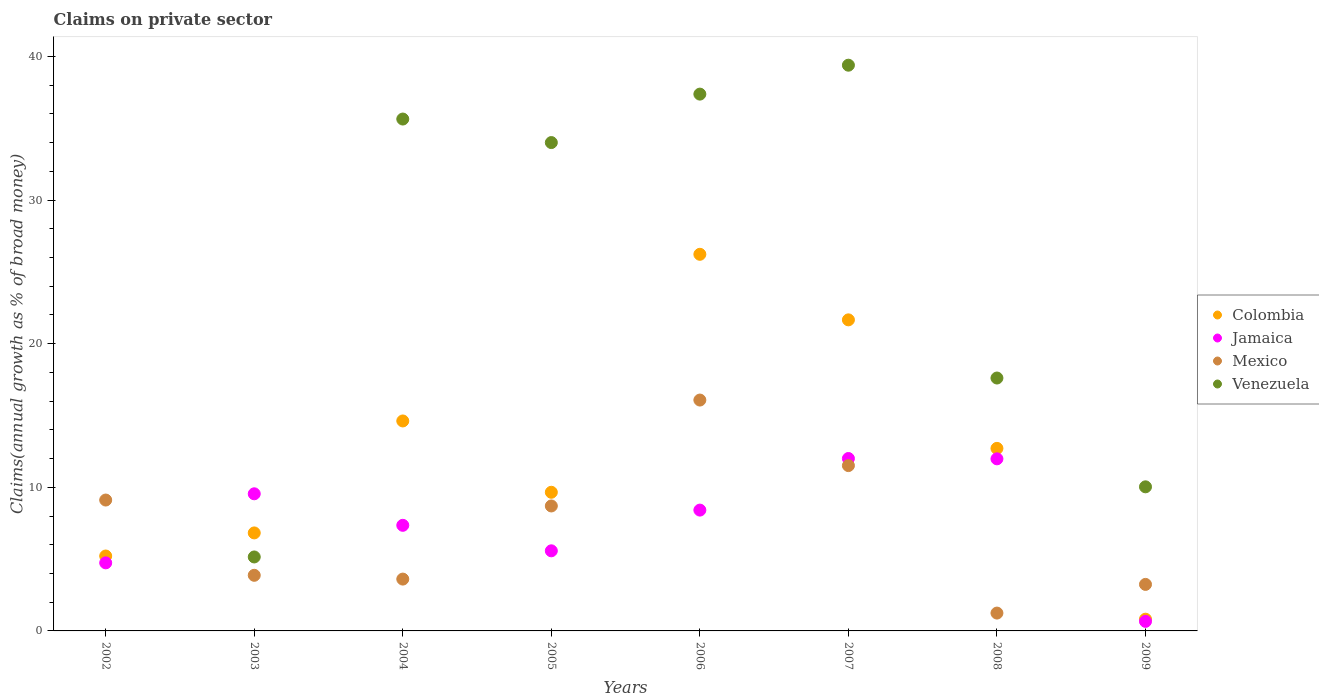How many different coloured dotlines are there?
Your answer should be very brief. 4. Is the number of dotlines equal to the number of legend labels?
Your answer should be compact. No. What is the percentage of broad money claimed on private sector in Colombia in 2008?
Your answer should be compact. 12.71. Across all years, what is the maximum percentage of broad money claimed on private sector in Mexico?
Your response must be concise. 16.08. Across all years, what is the minimum percentage of broad money claimed on private sector in Colombia?
Make the answer very short. 0.82. In which year was the percentage of broad money claimed on private sector in Colombia maximum?
Provide a short and direct response. 2006. What is the total percentage of broad money claimed on private sector in Colombia in the graph?
Provide a succinct answer. 97.73. What is the difference between the percentage of broad money claimed on private sector in Jamaica in 2002 and that in 2003?
Provide a succinct answer. -4.81. What is the difference between the percentage of broad money claimed on private sector in Venezuela in 2003 and the percentage of broad money claimed on private sector in Jamaica in 2007?
Provide a succinct answer. -6.86. What is the average percentage of broad money claimed on private sector in Venezuela per year?
Keep it short and to the point. 22.4. In the year 2007, what is the difference between the percentage of broad money claimed on private sector in Jamaica and percentage of broad money claimed on private sector in Venezuela?
Keep it short and to the point. -27.39. In how many years, is the percentage of broad money claimed on private sector in Colombia greater than 6 %?
Your answer should be compact. 6. What is the ratio of the percentage of broad money claimed on private sector in Venezuela in 2005 to that in 2008?
Offer a very short reply. 1.93. Is the percentage of broad money claimed on private sector in Mexico in 2003 less than that in 2004?
Your answer should be very brief. No. What is the difference between the highest and the second highest percentage of broad money claimed on private sector in Venezuela?
Make the answer very short. 2.01. What is the difference between the highest and the lowest percentage of broad money claimed on private sector in Mexico?
Your response must be concise. 14.83. In how many years, is the percentage of broad money claimed on private sector in Mexico greater than the average percentage of broad money claimed on private sector in Mexico taken over all years?
Give a very brief answer. 4. Is it the case that in every year, the sum of the percentage of broad money claimed on private sector in Jamaica and percentage of broad money claimed on private sector in Colombia  is greater than the percentage of broad money claimed on private sector in Mexico?
Your answer should be very brief. No. How many years are there in the graph?
Your answer should be compact. 8. What is the difference between two consecutive major ticks on the Y-axis?
Keep it short and to the point. 10. How many legend labels are there?
Provide a short and direct response. 4. How are the legend labels stacked?
Give a very brief answer. Vertical. What is the title of the graph?
Make the answer very short. Claims on private sector. Does "Ireland" appear as one of the legend labels in the graph?
Provide a succinct answer. No. What is the label or title of the Y-axis?
Ensure brevity in your answer.  Claims(annual growth as % of broad money). What is the Claims(annual growth as % of broad money) of Colombia in 2002?
Offer a terse response. 5.22. What is the Claims(annual growth as % of broad money) in Jamaica in 2002?
Provide a succinct answer. 4.74. What is the Claims(annual growth as % of broad money) of Mexico in 2002?
Provide a succinct answer. 9.11. What is the Claims(annual growth as % of broad money) in Colombia in 2003?
Your answer should be compact. 6.82. What is the Claims(annual growth as % of broad money) of Jamaica in 2003?
Provide a succinct answer. 9.55. What is the Claims(annual growth as % of broad money) of Mexico in 2003?
Offer a terse response. 3.87. What is the Claims(annual growth as % of broad money) in Venezuela in 2003?
Keep it short and to the point. 5.15. What is the Claims(annual growth as % of broad money) of Colombia in 2004?
Offer a terse response. 14.62. What is the Claims(annual growth as % of broad money) of Jamaica in 2004?
Your answer should be very brief. 7.35. What is the Claims(annual growth as % of broad money) in Mexico in 2004?
Offer a very short reply. 3.61. What is the Claims(annual growth as % of broad money) in Venezuela in 2004?
Provide a short and direct response. 35.64. What is the Claims(annual growth as % of broad money) of Colombia in 2005?
Keep it short and to the point. 9.66. What is the Claims(annual growth as % of broad money) in Jamaica in 2005?
Your response must be concise. 5.58. What is the Claims(annual growth as % of broad money) in Mexico in 2005?
Offer a very short reply. 8.7. What is the Claims(annual growth as % of broad money) in Venezuela in 2005?
Make the answer very short. 34.01. What is the Claims(annual growth as % of broad money) of Colombia in 2006?
Offer a terse response. 26.22. What is the Claims(annual growth as % of broad money) in Jamaica in 2006?
Give a very brief answer. 8.41. What is the Claims(annual growth as % of broad money) of Mexico in 2006?
Offer a terse response. 16.08. What is the Claims(annual growth as % of broad money) of Venezuela in 2006?
Offer a terse response. 37.38. What is the Claims(annual growth as % of broad money) of Colombia in 2007?
Your response must be concise. 21.66. What is the Claims(annual growth as % of broad money) in Jamaica in 2007?
Make the answer very short. 12.01. What is the Claims(annual growth as % of broad money) in Mexico in 2007?
Offer a very short reply. 11.51. What is the Claims(annual growth as % of broad money) in Venezuela in 2007?
Provide a succinct answer. 39.39. What is the Claims(annual growth as % of broad money) of Colombia in 2008?
Provide a succinct answer. 12.71. What is the Claims(annual growth as % of broad money) of Jamaica in 2008?
Make the answer very short. 11.98. What is the Claims(annual growth as % of broad money) in Mexico in 2008?
Make the answer very short. 1.24. What is the Claims(annual growth as % of broad money) in Venezuela in 2008?
Keep it short and to the point. 17.61. What is the Claims(annual growth as % of broad money) in Colombia in 2009?
Provide a succinct answer. 0.82. What is the Claims(annual growth as % of broad money) in Jamaica in 2009?
Your answer should be very brief. 0.66. What is the Claims(annual growth as % of broad money) of Mexico in 2009?
Your response must be concise. 3.24. What is the Claims(annual growth as % of broad money) of Venezuela in 2009?
Offer a terse response. 10.03. Across all years, what is the maximum Claims(annual growth as % of broad money) of Colombia?
Provide a succinct answer. 26.22. Across all years, what is the maximum Claims(annual growth as % of broad money) of Jamaica?
Your answer should be compact. 12.01. Across all years, what is the maximum Claims(annual growth as % of broad money) in Mexico?
Your response must be concise. 16.08. Across all years, what is the maximum Claims(annual growth as % of broad money) in Venezuela?
Provide a short and direct response. 39.39. Across all years, what is the minimum Claims(annual growth as % of broad money) of Colombia?
Ensure brevity in your answer.  0.82. Across all years, what is the minimum Claims(annual growth as % of broad money) of Jamaica?
Provide a short and direct response. 0.66. Across all years, what is the minimum Claims(annual growth as % of broad money) in Mexico?
Keep it short and to the point. 1.24. Across all years, what is the minimum Claims(annual growth as % of broad money) in Venezuela?
Your answer should be very brief. 0. What is the total Claims(annual growth as % of broad money) in Colombia in the graph?
Ensure brevity in your answer.  97.73. What is the total Claims(annual growth as % of broad money) of Jamaica in the graph?
Ensure brevity in your answer.  60.29. What is the total Claims(annual growth as % of broad money) in Mexico in the graph?
Offer a very short reply. 57.37. What is the total Claims(annual growth as % of broad money) in Venezuela in the graph?
Offer a terse response. 179.22. What is the difference between the Claims(annual growth as % of broad money) in Colombia in 2002 and that in 2003?
Your answer should be very brief. -1.61. What is the difference between the Claims(annual growth as % of broad money) of Jamaica in 2002 and that in 2003?
Make the answer very short. -4.81. What is the difference between the Claims(annual growth as % of broad money) of Mexico in 2002 and that in 2003?
Your answer should be very brief. 5.24. What is the difference between the Claims(annual growth as % of broad money) of Colombia in 2002 and that in 2004?
Offer a very short reply. -9.4. What is the difference between the Claims(annual growth as % of broad money) of Jamaica in 2002 and that in 2004?
Offer a terse response. -2.61. What is the difference between the Claims(annual growth as % of broad money) of Mexico in 2002 and that in 2004?
Give a very brief answer. 5.5. What is the difference between the Claims(annual growth as % of broad money) in Colombia in 2002 and that in 2005?
Keep it short and to the point. -4.44. What is the difference between the Claims(annual growth as % of broad money) of Jamaica in 2002 and that in 2005?
Provide a succinct answer. -0.84. What is the difference between the Claims(annual growth as % of broad money) of Mexico in 2002 and that in 2005?
Make the answer very short. 0.41. What is the difference between the Claims(annual growth as % of broad money) of Colombia in 2002 and that in 2006?
Offer a very short reply. -21.01. What is the difference between the Claims(annual growth as % of broad money) in Jamaica in 2002 and that in 2006?
Offer a terse response. -3.67. What is the difference between the Claims(annual growth as % of broad money) in Mexico in 2002 and that in 2006?
Offer a very short reply. -6.96. What is the difference between the Claims(annual growth as % of broad money) in Colombia in 2002 and that in 2007?
Your answer should be compact. -16.44. What is the difference between the Claims(annual growth as % of broad money) of Jamaica in 2002 and that in 2007?
Keep it short and to the point. -7.27. What is the difference between the Claims(annual growth as % of broad money) of Mexico in 2002 and that in 2007?
Give a very brief answer. -2.4. What is the difference between the Claims(annual growth as % of broad money) of Colombia in 2002 and that in 2008?
Provide a short and direct response. -7.5. What is the difference between the Claims(annual growth as % of broad money) of Jamaica in 2002 and that in 2008?
Offer a very short reply. -7.24. What is the difference between the Claims(annual growth as % of broad money) in Mexico in 2002 and that in 2008?
Offer a very short reply. 7.87. What is the difference between the Claims(annual growth as % of broad money) of Colombia in 2002 and that in 2009?
Your response must be concise. 4.4. What is the difference between the Claims(annual growth as % of broad money) in Jamaica in 2002 and that in 2009?
Your response must be concise. 4.08. What is the difference between the Claims(annual growth as % of broad money) in Mexico in 2002 and that in 2009?
Your answer should be very brief. 5.87. What is the difference between the Claims(annual growth as % of broad money) of Colombia in 2003 and that in 2004?
Offer a very short reply. -7.8. What is the difference between the Claims(annual growth as % of broad money) of Jamaica in 2003 and that in 2004?
Keep it short and to the point. 2.19. What is the difference between the Claims(annual growth as % of broad money) of Mexico in 2003 and that in 2004?
Make the answer very short. 0.26. What is the difference between the Claims(annual growth as % of broad money) of Venezuela in 2003 and that in 2004?
Your response must be concise. -30.49. What is the difference between the Claims(annual growth as % of broad money) in Colombia in 2003 and that in 2005?
Make the answer very short. -2.83. What is the difference between the Claims(annual growth as % of broad money) of Jamaica in 2003 and that in 2005?
Offer a very short reply. 3.97. What is the difference between the Claims(annual growth as % of broad money) of Mexico in 2003 and that in 2005?
Keep it short and to the point. -4.83. What is the difference between the Claims(annual growth as % of broad money) of Venezuela in 2003 and that in 2005?
Provide a short and direct response. -28.86. What is the difference between the Claims(annual growth as % of broad money) of Colombia in 2003 and that in 2006?
Your answer should be very brief. -19.4. What is the difference between the Claims(annual growth as % of broad money) of Jamaica in 2003 and that in 2006?
Make the answer very short. 1.14. What is the difference between the Claims(annual growth as % of broad money) of Mexico in 2003 and that in 2006?
Offer a terse response. -12.2. What is the difference between the Claims(annual growth as % of broad money) in Venezuela in 2003 and that in 2006?
Ensure brevity in your answer.  -32.23. What is the difference between the Claims(annual growth as % of broad money) of Colombia in 2003 and that in 2007?
Your answer should be very brief. -14.84. What is the difference between the Claims(annual growth as % of broad money) in Jamaica in 2003 and that in 2007?
Offer a terse response. -2.46. What is the difference between the Claims(annual growth as % of broad money) in Mexico in 2003 and that in 2007?
Provide a succinct answer. -7.64. What is the difference between the Claims(annual growth as % of broad money) in Venezuela in 2003 and that in 2007?
Provide a succinct answer. -34.24. What is the difference between the Claims(annual growth as % of broad money) of Colombia in 2003 and that in 2008?
Ensure brevity in your answer.  -5.89. What is the difference between the Claims(annual growth as % of broad money) of Jamaica in 2003 and that in 2008?
Offer a very short reply. -2.43. What is the difference between the Claims(annual growth as % of broad money) in Mexico in 2003 and that in 2008?
Your answer should be compact. 2.63. What is the difference between the Claims(annual growth as % of broad money) of Venezuela in 2003 and that in 2008?
Ensure brevity in your answer.  -12.46. What is the difference between the Claims(annual growth as % of broad money) of Colombia in 2003 and that in 2009?
Your response must be concise. 6.01. What is the difference between the Claims(annual growth as % of broad money) in Jamaica in 2003 and that in 2009?
Keep it short and to the point. 8.88. What is the difference between the Claims(annual growth as % of broad money) in Mexico in 2003 and that in 2009?
Offer a very short reply. 0.63. What is the difference between the Claims(annual growth as % of broad money) in Venezuela in 2003 and that in 2009?
Your response must be concise. -4.88. What is the difference between the Claims(annual growth as % of broad money) of Colombia in 2004 and that in 2005?
Ensure brevity in your answer.  4.97. What is the difference between the Claims(annual growth as % of broad money) in Jamaica in 2004 and that in 2005?
Keep it short and to the point. 1.78. What is the difference between the Claims(annual growth as % of broad money) in Mexico in 2004 and that in 2005?
Your answer should be compact. -5.09. What is the difference between the Claims(annual growth as % of broad money) in Venezuela in 2004 and that in 2005?
Offer a very short reply. 1.64. What is the difference between the Claims(annual growth as % of broad money) in Colombia in 2004 and that in 2006?
Give a very brief answer. -11.6. What is the difference between the Claims(annual growth as % of broad money) of Jamaica in 2004 and that in 2006?
Keep it short and to the point. -1.06. What is the difference between the Claims(annual growth as % of broad money) in Mexico in 2004 and that in 2006?
Offer a very short reply. -12.47. What is the difference between the Claims(annual growth as % of broad money) of Venezuela in 2004 and that in 2006?
Provide a succinct answer. -1.74. What is the difference between the Claims(annual growth as % of broad money) in Colombia in 2004 and that in 2007?
Your answer should be very brief. -7.04. What is the difference between the Claims(annual growth as % of broad money) of Jamaica in 2004 and that in 2007?
Provide a short and direct response. -4.65. What is the difference between the Claims(annual growth as % of broad money) in Mexico in 2004 and that in 2007?
Your response must be concise. -7.9. What is the difference between the Claims(annual growth as % of broad money) of Venezuela in 2004 and that in 2007?
Your response must be concise. -3.75. What is the difference between the Claims(annual growth as % of broad money) of Colombia in 2004 and that in 2008?
Ensure brevity in your answer.  1.91. What is the difference between the Claims(annual growth as % of broad money) of Jamaica in 2004 and that in 2008?
Keep it short and to the point. -4.63. What is the difference between the Claims(annual growth as % of broad money) in Mexico in 2004 and that in 2008?
Give a very brief answer. 2.37. What is the difference between the Claims(annual growth as % of broad money) of Venezuela in 2004 and that in 2008?
Offer a terse response. 18.03. What is the difference between the Claims(annual growth as % of broad money) in Colombia in 2004 and that in 2009?
Your response must be concise. 13.8. What is the difference between the Claims(annual growth as % of broad money) of Jamaica in 2004 and that in 2009?
Make the answer very short. 6.69. What is the difference between the Claims(annual growth as % of broad money) in Mexico in 2004 and that in 2009?
Provide a short and direct response. 0.37. What is the difference between the Claims(annual growth as % of broad money) of Venezuela in 2004 and that in 2009?
Your answer should be very brief. 25.61. What is the difference between the Claims(annual growth as % of broad money) in Colombia in 2005 and that in 2006?
Your answer should be very brief. -16.57. What is the difference between the Claims(annual growth as % of broad money) in Jamaica in 2005 and that in 2006?
Ensure brevity in your answer.  -2.84. What is the difference between the Claims(annual growth as % of broad money) of Mexico in 2005 and that in 2006?
Offer a very short reply. -7.37. What is the difference between the Claims(annual growth as % of broad money) in Venezuela in 2005 and that in 2006?
Your answer should be very brief. -3.37. What is the difference between the Claims(annual growth as % of broad money) of Colombia in 2005 and that in 2007?
Provide a succinct answer. -12.01. What is the difference between the Claims(annual growth as % of broad money) in Jamaica in 2005 and that in 2007?
Provide a short and direct response. -6.43. What is the difference between the Claims(annual growth as % of broad money) of Mexico in 2005 and that in 2007?
Give a very brief answer. -2.81. What is the difference between the Claims(annual growth as % of broad money) in Venezuela in 2005 and that in 2007?
Your answer should be compact. -5.39. What is the difference between the Claims(annual growth as % of broad money) of Colombia in 2005 and that in 2008?
Offer a very short reply. -3.06. What is the difference between the Claims(annual growth as % of broad money) in Jamaica in 2005 and that in 2008?
Keep it short and to the point. -6.41. What is the difference between the Claims(annual growth as % of broad money) of Mexico in 2005 and that in 2008?
Your answer should be very brief. 7.46. What is the difference between the Claims(annual growth as % of broad money) in Venezuela in 2005 and that in 2008?
Make the answer very short. 16.4. What is the difference between the Claims(annual growth as % of broad money) in Colombia in 2005 and that in 2009?
Keep it short and to the point. 8.84. What is the difference between the Claims(annual growth as % of broad money) in Jamaica in 2005 and that in 2009?
Your answer should be compact. 4.91. What is the difference between the Claims(annual growth as % of broad money) in Mexico in 2005 and that in 2009?
Make the answer very short. 5.46. What is the difference between the Claims(annual growth as % of broad money) of Venezuela in 2005 and that in 2009?
Offer a terse response. 23.97. What is the difference between the Claims(annual growth as % of broad money) of Colombia in 2006 and that in 2007?
Offer a very short reply. 4.56. What is the difference between the Claims(annual growth as % of broad money) in Jamaica in 2006 and that in 2007?
Provide a succinct answer. -3.59. What is the difference between the Claims(annual growth as % of broad money) of Mexico in 2006 and that in 2007?
Offer a very short reply. 4.56. What is the difference between the Claims(annual growth as % of broad money) in Venezuela in 2006 and that in 2007?
Your answer should be compact. -2.01. What is the difference between the Claims(annual growth as % of broad money) in Colombia in 2006 and that in 2008?
Your response must be concise. 13.51. What is the difference between the Claims(annual growth as % of broad money) in Jamaica in 2006 and that in 2008?
Ensure brevity in your answer.  -3.57. What is the difference between the Claims(annual growth as % of broad money) in Mexico in 2006 and that in 2008?
Your answer should be compact. 14.83. What is the difference between the Claims(annual growth as % of broad money) of Venezuela in 2006 and that in 2008?
Your answer should be very brief. 19.77. What is the difference between the Claims(annual growth as % of broad money) in Colombia in 2006 and that in 2009?
Give a very brief answer. 25.41. What is the difference between the Claims(annual growth as % of broad money) of Jamaica in 2006 and that in 2009?
Offer a terse response. 7.75. What is the difference between the Claims(annual growth as % of broad money) of Mexico in 2006 and that in 2009?
Ensure brevity in your answer.  12.84. What is the difference between the Claims(annual growth as % of broad money) of Venezuela in 2006 and that in 2009?
Give a very brief answer. 27.35. What is the difference between the Claims(annual growth as % of broad money) in Colombia in 2007 and that in 2008?
Your response must be concise. 8.95. What is the difference between the Claims(annual growth as % of broad money) of Jamaica in 2007 and that in 2008?
Your response must be concise. 0.02. What is the difference between the Claims(annual growth as % of broad money) of Mexico in 2007 and that in 2008?
Offer a very short reply. 10.27. What is the difference between the Claims(annual growth as % of broad money) in Venezuela in 2007 and that in 2008?
Give a very brief answer. 21.78. What is the difference between the Claims(annual growth as % of broad money) of Colombia in 2007 and that in 2009?
Give a very brief answer. 20.84. What is the difference between the Claims(annual growth as % of broad money) in Jamaica in 2007 and that in 2009?
Provide a short and direct response. 11.34. What is the difference between the Claims(annual growth as % of broad money) of Mexico in 2007 and that in 2009?
Your answer should be compact. 8.27. What is the difference between the Claims(annual growth as % of broad money) in Venezuela in 2007 and that in 2009?
Provide a succinct answer. 29.36. What is the difference between the Claims(annual growth as % of broad money) in Colombia in 2008 and that in 2009?
Your answer should be very brief. 11.89. What is the difference between the Claims(annual growth as % of broad money) of Jamaica in 2008 and that in 2009?
Your answer should be very brief. 11.32. What is the difference between the Claims(annual growth as % of broad money) in Mexico in 2008 and that in 2009?
Give a very brief answer. -2. What is the difference between the Claims(annual growth as % of broad money) in Venezuela in 2008 and that in 2009?
Give a very brief answer. 7.58. What is the difference between the Claims(annual growth as % of broad money) of Colombia in 2002 and the Claims(annual growth as % of broad money) of Jamaica in 2003?
Provide a succinct answer. -4.33. What is the difference between the Claims(annual growth as % of broad money) of Colombia in 2002 and the Claims(annual growth as % of broad money) of Mexico in 2003?
Provide a succinct answer. 1.34. What is the difference between the Claims(annual growth as % of broad money) of Colombia in 2002 and the Claims(annual growth as % of broad money) of Venezuela in 2003?
Offer a very short reply. 0.07. What is the difference between the Claims(annual growth as % of broad money) of Jamaica in 2002 and the Claims(annual growth as % of broad money) of Mexico in 2003?
Ensure brevity in your answer.  0.87. What is the difference between the Claims(annual growth as % of broad money) of Jamaica in 2002 and the Claims(annual growth as % of broad money) of Venezuela in 2003?
Your response must be concise. -0.41. What is the difference between the Claims(annual growth as % of broad money) in Mexico in 2002 and the Claims(annual growth as % of broad money) in Venezuela in 2003?
Offer a very short reply. 3.96. What is the difference between the Claims(annual growth as % of broad money) of Colombia in 2002 and the Claims(annual growth as % of broad money) of Jamaica in 2004?
Your response must be concise. -2.14. What is the difference between the Claims(annual growth as % of broad money) in Colombia in 2002 and the Claims(annual growth as % of broad money) in Mexico in 2004?
Your answer should be very brief. 1.61. What is the difference between the Claims(annual growth as % of broad money) in Colombia in 2002 and the Claims(annual growth as % of broad money) in Venezuela in 2004?
Give a very brief answer. -30.43. What is the difference between the Claims(annual growth as % of broad money) in Jamaica in 2002 and the Claims(annual growth as % of broad money) in Mexico in 2004?
Offer a very short reply. 1.13. What is the difference between the Claims(annual growth as % of broad money) of Jamaica in 2002 and the Claims(annual growth as % of broad money) of Venezuela in 2004?
Provide a short and direct response. -30.9. What is the difference between the Claims(annual growth as % of broad money) of Mexico in 2002 and the Claims(annual growth as % of broad money) of Venezuela in 2004?
Your answer should be very brief. -26.53. What is the difference between the Claims(annual growth as % of broad money) in Colombia in 2002 and the Claims(annual growth as % of broad money) in Jamaica in 2005?
Make the answer very short. -0.36. What is the difference between the Claims(annual growth as % of broad money) of Colombia in 2002 and the Claims(annual growth as % of broad money) of Mexico in 2005?
Provide a short and direct response. -3.48. What is the difference between the Claims(annual growth as % of broad money) in Colombia in 2002 and the Claims(annual growth as % of broad money) in Venezuela in 2005?
Give a very brief answer. -28.79. What is the difference between the Claims(annual growth as % of broad money) of Jamaica in 2002 and the Claims(annual growth as % of broad money) of Mexico in 2005?
Offer a terse response. -3.96. What is the difference between the Claims(annual growth as % of broad money) of Jamaica in 2002 and the Claims(annual growth as % of broad money) of Venezuela in 2005?
Make the answer very short. -29.27. What is the difference between the Claims(annual growth as % of broad money) of Mexico in 2002 and the Claims(annual growth as % of broad money) of Venezuela in 2005?
Offer a very short reply. -24.89. What is the difference between the Claims(annual growth as % of broad money) in Colombia in 2002 and the Claims(annual growth as % of broad money) in Jamaica in 2006?
Give a very brief answer. -3.2. What is the difference between the Claims(annual growth as % of broad money) of Colombia in 2002 and the Claims(annual growth as % of broad money) of Mexico in 2006?
Offer a very short reply. -10.86. What is the difference between the Claims(annual growth as % of broad money) of Colombia in 2002 and the Claims(annual growth as % of broad money) of Venezuela in 2006?
Offer a terse response. -32.16. What is the difference between the Claims(annual growth as % of broad money) of Jamaica in 2002 and the Claims(annual growth as % of broad money) of Mexico in 2006?
Keep it short and to the point. -11.34. What is the difference between the Claims(annual growth as % of broad money) of Jamaica in 2002 and the Claims(annual growth as % of broad money) of Venezuela in 2006?
Provide a succinct answer. -32.64. What is the difference between the Claims(annual growth as % of broad money) in Mexico in 2002 and the Claims(annual growth as % of broad money) in Venezuela in 2006?
Make the answer very short. -28.27. What is the difference between the Claims(annual growth as % of broad money) of Colombia in 2002 and the Claims(annual growth as % of broad money) of Jamaica in 2007?
Keep it short and to the point. -6.79. What is the difference between the Claims(annual growth as % of broad money) in Colombia in 2002 and the Claims(annual growth as % of broad money) in Mexico in 2007?
Provide a short and direct response. -6.3. What is the difference between the Claims(annual growth as % of broad money) in Colombia in 2002 and the Claims(annual growth as % of broad money) in Venezuela in 2007?
Give a very brief answer. -34.18. What is the difference between the Claims(annual growth as % of broad money) of Jamaica in 2002 and the Claims(annual growth as % of broad money) of Mexico in 2007?
Make the answer very short. -6.77. What is the difference between the Claims(annual growth as % of broad money) of Jamaica in 2002 and the Claims(annual growth as % of broad money) of Venezuela in 2007?
Provide a short and direct response. -34.65. What is the difference between the Claims(annual growth as % of broad money) of Mexico in 2002 and the Claims(annual growth as % of broad money) of Venezuela in 2007?
Give a very brief answer. -30.28. What is the difference between the Claims(annual growth as % of broad money) of Colombia in 2002 and the Claims(annual growth as % of broad money) of Jamaica in 2008?
Your response must be concise. -6.77. What is the difference between the Claims(annual growth as % of broad money) of Colombia in 2002 and the Claims(annual growth as % of broad money) of Mexico in 2008?
Give a very brief answer. 3.97. What is the difference between the Claims(annual growth as % of broad money) in Colombia in 2002 and the Claims(annual growth as % of broad money) in Venezuela in 2008?
Your response must be concise. -12.39. What is the difference between the Claims(annual growth as % of broad money) in Jamaica in 2002 and the Claims(annual growth as % of broad money) in Mexico in 2008?
Make the answer very short. 3.5. What is the difference between the Claims(annual growth as % of broad money) in Jamaica in 2002 and the Claims(annual growth as % of broad money) in Venezuela in 2008?
Your response must be concise. -12.87. What is the difference between the Claims(annual growth as % of broad money) of Mexico in 2002 and the Claims(annual growth as % of broad money) of Venezuela in 2008?
Keep it short and to the point. -8.5. What is the difference between the Claims(annual growth as % of broad money) in Colombia in 2002 and the Claims(annual growth as % of broad money) in Jamaica in 2009?
Keep it short and to the point. 4.55. What is the difference between the Claims(annual growth as % of broad money) in Colombia in 2002 and the Claims(annual growth as % of broad money) in Mexico in 2009?
Your answer should be compact. 1.98. What is the difference between the Claims(annual growth as % of broad money) of Colombia in 2002 and the Claims(annual growth as % of broad money) of Venezuela in 2009?
Keep it short and to the point. -4.82. What is the difference between the Claims(annual growth as % of broad money) in Jamaica in 2002 and the Claims(annual growth as % of broad money) in Mexico in 2009?
Keep it short and to the point. 1.5. What is the difference between the Claims(annual growth as % of broad money) in Jamaica in 2002 and the Claims(annual growth as % of broad money) in Venezuela in 2009?
Your answer should be very brief. -5.29. What is the difference between the Claims(annual growth as % of broad money) in Mexico in 2002 and the Claims(annual growth as % of broad money) in Venezuela in 2009?
Your answer should be very brief. -0.92. What is the difference between the Claims(annual growth as % of broad money) in Colombia in 2003 and the Claims(annual growth as % of broad money) in Jamaica in 2004?
Your response must be concise. -0.53. What is the difference between the Claims(annual growth as % of broad money) of Colombia in 2003 and the Claims(annual growth as % of broad money) of Mexico in 2004?
Your answer should be compact. 3.22. What is the difference between the Claims(annual growth as % of broad money) in Colombia in 2003 and the Claims(annual growth as % of broad money) in Venezuela in 2004?
Give a very brief answer. -28.82. What is the difference between the Claims(annual growth as % of broad money) in Jamaica in 2003 and the Claims(annual growth as % of broad money) in Mexico in 2004?
Keep it short and to the point. 5.94. What is the difference between the Claims(annual growth as % of broad money) in Jamaica in 2003 and the Claims(annual growth as % of broad money) in Venezuela in 2004?
Make the answer very short. -26.1. What is the difference between the Claims(annual growth as % of broad money) of Mexico in 2003 and the Claims(annual growth as % of broad money) of Venezuela in 2004?
Make the answer very short. -31.77. What is the difference between the Claims(annual growth as % of broad money) in Colombia in 2003 and the Claims(annual growth as % of broad money) in Jamaica in 2005?
Provide a short and direct response. 1.25. What is the difference between the Claims(annual growth as % of broad money) of Colombia in 2003 and the Claims(annual growth as % of broad money) of Mexico in 2005?
Your answer should be very brief. -1.88. What is the difference between the Claims(annual growth as % of broad money) in Colombia in 2003 and the Claims(annual growth as % of broad money) in Venezuela in 2005?
Provide a short and direct response. -27.18. What is the difference between the Claims(annual growth as % of broad money) in Jamaica in 2003 and the Claims(annual growth as % of broad money) in Mexico in 2005?
Your answer should be compact. 0.85. What is the difference between the Claims(annual growth as % of broad money) in Jamaica in 2003 and the Claims(annual growth as % of broad money) in Venezuela in 2005?
Your response must be concise. -24.46. What is the difference between the Claims(annual growth as % of broad money) in Mexico in 2003 and the Claims(annual growth as % of broad money) in Venezuela in 2005?
Offer a very short reply. -30.13. What is the difference between the Claims(annual growth as % of broad money) in Colombia in 2003 and the Claims(annual growth as % of broad money) in Jamaica in 2006?
Offer a very short reply. -1.59. What is the difference between the Claims(annual growth as % of broad money) of Colombia in 2003 and the Claims(annual growth as % of broad money) of Mexico in 2006?
Provide a short and direct response. -9.25. What is the difference between the Claims(annual growth as % of broad money) of Colombia in 2003 and the Claims(annual growth as % of broad money) of Venezuela in 2006?
Keep it short and to the point. -30.56. What is the difference between the Claims(annual growth as % of broad money) of Jamaica in 2003 and the Claims(annual growth as % of broad money) of Mexico in 2006?
Offer a very short reply. -6.53. What is the difference between the Claims(annual growth as % of broad money) in Jamaica in 2003 and the Claims(annual growth as % of broad money) in Venezuela in 2006?
Provide a short and direct response. -27.83. What is the difference between the Claims(annual growth as % of broad money) in Mexico in 2003 and the Claims(annual growth as % of broad money) in Venezuela in 2006?
Offer a terse response. -33.51. What is the difference between the Claims(annual growth as % of broad money) in Colombia in 2003 and the Claims(annual growth as % of broad money) in Jamaica in 2007?
Your answer should be compact. -5.18. What is the difference between the Claims(annual growth as % of broad money) of Colombia in 2003 and the Claims(annual growth as % of broad money) of Mexico in 2007?
Keep it short and to the point. -4.69. What is the difference between the Claims(annual growth as % of broad money) of Colombia in 2003 and the Claims(annual growth as % of broad money) of Venezuela in 2007?
Keep it short and to the point. -32.57. What is the difference between the Claims(annual growth as % of broad money) of Jamaica in 2003 and the Claims(annual growth as % of broad money) of Mexico in 2007?
Make the answer very short. -1.96. What is the difference between the Claims(annual growth as % of broad money) in Jamaica in 2003 and the Claims(annual growth as % of broad money) in Venezuela in 2007?
Your answer should be compact. -29.85. What is the difference between the Claims(annual growth as % of broad money) in Mexico in 2003 and the Claims(annual growth as % of broad money) in Venezuela in 2007?
Keep it short and to the point. -35.52. What is the difference between the Claims(annual growth as % of broad money) of Colombia in 2003 and the Claims(annual growth as % of broad money) of Jamaica in 2008?
Your answer should be very brief. -5.16. What is the difference between the Claims(annual growth as % of broad money) in Colombia in 2003 and the Claims(annual growth as % of broad money) in Mexico in 2008?
Your answer should be very brief. 5.58. What is the difference between the Claims(annual growth as % of broad money) in Colombia in 2003 and the Claims(annual growth as % of broad money) in Venezuela in 2008?
Provide a succinct answer. -10.79. What is the difference between the Claims(annual growth as % of broad money) in Jamaica in 2003 and the Claims(annual growth as % of broad money) in Mexico in 2008?
Your answer should be very brief. 8.31. What is the difference between the Claims(annual growth as % of broad money) in Jamaica in 2003 and the Claims(annual growth as % of broad money) in Venezuela in 2008?
Your answer should be compact. -8.06. What is the difference between the Claims(annual growth as % of broad money) in Mexico in 2003 and the Claims(annual growth as % of broad money) in Venezuela in 2008?
Your answer should be very brief. -13.74. What is the difference between the Claims(annual growth as % of broad money) of Colombia in 2003 and the Claims(annual growth as % of broad money) of Jamaica in 2009?
Ensure brevity in your answer.  6.16. What is the difference between the Claims(annual growth as % of broad money) of Colombia in 2003 and the Claims(annual growth as % of broad money) of Mexico in 2009?
Give a very brief answer. 3.58. What is the difference between the Claims(annual growth as % of broad money) of Colombia in 2003 and the Claims(annual growth as % of broad money) of Venezuela in 2009?
Offer a very short reply. -3.21. What is the difference between the Claims(annual growth as % of broad money) in Jamaica in 2003 and the Claims(annual growth as % of broad money) in Mexico in 2009?
Offer a very short reply. 6.31. What is the difference between the Claims(annual growth as % of broad money) in Jamaica in 2003 and the Claims(annual growth as % of broad money) in Venezuela in 2009?
Your answer should be compact. -0.49. What is the difference between the Claims(annual growth as % of broad money) of Mexico in 2003 and the Claims(annual growth as % of broad money) of Venezuela in 2009?
Your answer should be very brief. -6.16. What is the difference between the Claims(annual growth as % of broad money) in Colombia in 2004 and the Claims(annual growth as % of broad money) in Jamaica in 2005?
Provide a succinct answer. 9.04. What is the difference between the Claims(annual growth as % of broad money) in Colombia in 2004 and the Claims(annual growth as % of broad money) in Mexico in 2005?
Give a very brief answer. 5.92. What is the difference between the Claims(annual growth as % of broad money) in Colombia in 2004 and the Claims(annual growth as % of broad money) in Venezuela in 2005?
Provide a short and direct response. -19.38. What is the difference between the Claims(annual growth as % of broad money) in Jamaica in 2004 and the Claims(annual growth as % of broad money) in Mexico in 2005?
Your response must be concise. -1.35. What is the difference between the Claims(annual growth as % of broad money) in Jamaica in 2004 and the Claims(annual growth as % of broad money) in Venezuela in 2005?
Your response must be concise. -26.65. What is the difference between the Claims(annual growth as % of broad money) of Mexico in 2004 and the Claims(annual growth as % of broad money) of Venezuela in 2005?
Make the answer very short. -30.4. What is the difference between the Claims(annual growth as % of broad money) in Colombia in 2004 and the Claims(annual growth as % of broad money) in Jamaica in 2006?
Make the answer very short. 6.21. What is the difference between the Claims(annual growth as % of broad money) of Colombia in 2004 and the Claims(annual growth as % of broad money) of Mexico in 2006?
Your answer should be very brief. -1.46. What is the difference between the Claims(annual growth as % of broad money) of Colombia in 2004 and the Claims(annual growth as % of broad money) of Venezuela in 2006?
Your response must be concise. -22.76. What is the difference between the Claims(annual growth as % of broad money) in Jamaica in 2004 and the Claims(annual growth as % of broad money) in Mexico in 2006?
Ensure brevity in your answer.  -8.72. What is the difference between the Claims(annual growth as % of broad money) in Jamaica in 2004 and the Claims(annual growth as % of broad money) in Venezuela in 2006?
Make the answer very short. -30.03. What is the difference between the Claims(annual growth as % of broad money) in Mexico in 2004 and the Claims(annual growth as % of broad money) in Venezuela in 2006?
Keep it short and to the point. -33.77. What is the difference between the Claims(annual growth as % of broad money) in Colombia in 2004 and the Claims(annual growth as % of broad money) in Jamaica in 2007?
Offer a very short reply. 2.62. What is the difference between the Claims(annual growth as % of broad money) in Colombia in 2004 and the Claims(annual growth as % of broad money) in Mexico in 2007?
Offer a terse response. 3.11. What is the difference between the Claims(annual growth as % of broad money) in Colombia in 2004 and the Claims(annual growth as % of broad money) in Venezuela in 2007?
Give a very brief answer. -24.77. What is the difference between the Claims(annual growth as % of broad money) of Jamaica in 2004 and the Claims(annual growth as % of broad money) of Mexico in 2007?
Your answer should be very brief. -4.16. What is the difference between the Claims(annual growth as % of broad money) in Jamaica in 2004 and the Claims(annual growth as % of broad money) in Venezuela in 2007?
Provide a short and direct response. -32.04. What is the difference between the Claims(annual growth as % of broad money) of Mexico in 2004 and the Claims(annual growth as % of broad money) of Venezuela in 2007?
Provide a succinct answer. -35.78. What is the difference between the Claims(annual growth as % of broad money) of Colombia in 2004 and the Claims(annual growth as % of broad money) of Jamaica in 2008?
Provide a succinct answer. 2.64. What is the difference between the Claims(annual growth as % of broad money) of Colombia in 2004 and the Claims(annual growth as % of broad money) of Mexico in 2008?
Provide a short and direct response. 13.38. What is the difference between the Claims(annual growth as % of broad money) in Colombia in 2004 and the Claims(annual growth as % of broad money) in Venezuela in 2008?
Make the answer very short. -2.99. What is the difference between the Claims(annual growth as % of broad money) of Jamaica in 2004 and the Claims(annual growth as % of broad money) of Mexico in 2008?
Provide a short and direct response. 6.11. What is the difference between the Claims(annual growth as % of broad money) of Jamaica in 2004 and the Claims(annual growth as % of broad money) of Venezuela in 2008?
Offer a very short reply. -10.26. What is the difference between the Claims(annual growth as % of broad money) in Mexico in 2004 and the Claims(annual growth as % of broad money) in Venezuela in 2008?
Provide a short and direct response. -14. What is the difference between the Claims(annual growth as % of broad money) of Colombia in 2004 and the Claims(annual growth as % of broad money) of Jamaica in 2009?
Ensure brevity in your answer.  13.96. What is the difference between the Claims(annual growth as % of broad money) of Colombia in 2004 and the Claims(annual growth as % of broad money) of Mexico in 2009?
Provide a short and direct response. 11.38. What is the difference between the Claims(annual growth as % of broad money) in Colombia in 2004 and the Claims(annual growth as % of broad money) in Venezuela in 2009?
Provide a short and direct response. 4.59. What is the difference between the Claims(annual growth as % of broad money) of Jamaica in 2004 and the Claims(annual growth as % of broad money) of Mexico in 2009?
Your answer should be very brief. 4.11. What is the difference between the Claims(annual growth as % of broad money) of Jamaica in 2004 and the Claims(annual growth as % of broad money) of Venezuela in 2009?
Offer a terse response. -2.68. What is the difference between the Claims(annual growth as % of broad money) of Mexico in 2004 and the Claims(annual growth as % of broad money) of Venezuela in 2009?
Keep it short and to the point. -6.42. What is the difference between the Claims(annual growth as % of broad money) of Colombia in 2005 and the Claims(annual growth as % of broad money) of Jamaica in 2006?
Your answer should be very brief. 1.24. What is the difference between the Claims(annual growth as % of broad money) in Colombia in 2005 and the Claims(annual growth as % of broad money) in Mexico in 2006?
Offer a very short reply. -6.42. What is the difference between the Claims(annual growth as % of broad money) of Colombia in 2005 and the Claims(annual growth as % of broad money) of Venezuela in 2006?
Your answer should be very brief. -27.72. What is the difference between the Claims(annual growth as % of broad money) of Jamaica in 2005 and the Claims(annual growth as % of broad money) of Mexico in 2006?
Make the answer very short. -10.5. What is the difference between the Claims(annual growth as % of broad money) in Jamaica in 2005 and the Claims(annual growth as % of broad money) in Venezuela in 2006?
Make the answer very short. -31.8. What is the difference between the Claims(annual growth as % of broad money) in Mexico in 2005 and the Claims(annual growth as % of broad money) in Venezuela in 2006?
Your answer should be very brief. -28.68. What is the difference between the Claims(annual growth as % of broad money) of Colombia in 2005 and the Claims(annual growth as % of broad money) of Jamaica in 2007?
Make the answer very short. -2.35. What is the difference between the Claims(annual growth as % of broad money) in Colombia in 2005 and the Claims(annual growth as % of broad money) in Mexico in 2007?
Keep it short and to the point. -1.86. What is the difference between the Claims(annual growth as % of broad money) of Colombia in 2005 and the Claims(annual growth as % of broad money) of Venezuela in 2007?
Make the answer very short. -29.74. What is the difference between the Claims(annual growth as % of broad money) of Jamaica in 2005 and the Claims(annual growth as % of broad money) of Mexico in 2007?
Your answer should be very brief. -5.93. What is the difference between the Claims(annual growth as % of broad money) in Jamaica in 2005 and the Claims(annual growth as % of broad money) in Venezuela in 2007?
Provide a succinct answer. -33.82. What is the difference between the Claims(annual growth as % of broad money) of Mexico in 2005 and the Claims(annual growth as % of broad money) of Venezuela in 2007?
Provide a succinct answer. -30.69. What is the difference between the Claims(annual growth as % of broad money) of Colombia in 2005 and the Claims(annual growth as % of broad money) of Jamaica in 2008?
Provide a succinct answer. -2.33. What is the difference between the Claims(annual growth as % of broad money) in Colombia in 2005 and the Claims(annual growth as % of broad money) in Mexico in 2008?
Offer a very short reply. 8.41. What is the difference between the Claims(annual growth as % of broad money) of Colombia in 2005 and the Claims(annual growth as % of broad money) of Venezuela in 2008?
Provide a succinct answer. -7.95. What is the difference between the Claims(annual growth as % of broad money) of Jamaica in 2005 and the Claims(annual growth as % of broad money) of Mexico in 2008?
Provide a succinct answer. 4.34. What is the difference between the Claims(annual growth as % of broad money) of Jamaica in 2005 and the Claims(annual growth as % of broad money) of Venezuela in 2008?
Offer a terse response. -12.03. What is the difference between the Claims(annual growth as % of broad money) in Mexico in 2005 and the Claims(annual growth as % of broad money) in Venezuela in 2008?
Offer a terse response. -8.91. What is the difference between the Claims(annual growth as % of broad money) of Colombia in 2005 and the Claims(annual growth as % of broad money) of Jamaica in 2009?
Your answer should be very brief. 8.99. What is the difference between the Claims(annual growth as % of broad money) in Colombia in 2005 and the Claims(annual growth as % of broad money) in Mexico in 2009?
Ensure brevity in your answer.  6.42. What is the difference between the Claims(annual growth as % of broad money) of Colombia in 2005 and the Claims(annual growth as % of broad money) of Venezuela in 2009?
Offer a very short reply. -0.38. What is the difference between the Claims(annual growth as % of broad money) in Jamaica in 2005 and the Claims(annual growth as % of broad money) in Mexico in 2009?
Ensure brevity in your answer.  2.34. What is the difference between the Claims(annual growth as % of broad money) of Jamaica in 2005 and the Claims(annual growth as % of broad money) of Venezuela in 2009?
Offer a terse response. -4.46. What is the difference between the Claims(annual growth as % of broad money) of Mexico in 2005 and the Claims(annual growth as % of broad money) of Venezuela in 2009?
Your response must be concise. -1.33. What is the difference between the Claims(annual growth as % of broad money) in Colombia in 2006 and the Claims(annual growth as % of broad money) in Jamaica in 2007?
Give a very brief answer. 14.22. What is the difference between the Claims(annual growth as % of broad money) in Colombia in 2006 and the Claims(annual growth as % of broad money) in Mexico in 2007?
Offer a very short reply. 14.71. What is the difference between the Claims(annual growth as % of broad money) in Colombia in 2006 and the Claims(annual growth as % of broad money) in Venezuela in 2007?
Your answer should be compact. -13.17. What is the difference between the Claims(annual growth as % of broad money) in Jamaica in 2006 and the Claims(annual growth as % of broad money) in Mexico in 2007?
Give a very brief answer. -3.1. What is the difference between the Claims(annual growth as % of broad money) in Jamaica in 2006 and the Claims(annual growth as % of broad money) in Venezuela in 2007?
Offer a terse response. -30.98. What is the difference between the Claims(annual growth as % of broad money) in Mexico in 2006 and the Claims(annual growth as % of broad money) in Venezuela in 2007?
Provide a succinct answer. -23.32. What is the difference between the Claims(annual growth as % of broad money) of Colombia in 2006 and the Claims(annual growth as % of broad money) of Jamaica in 2008?
Provide a succinct answer. 14.24. What is the difference between the Claims(annual growth as % of broad money) of Colombia in 2006 and the Claims(annual growth as % of broad money) of Mexico in 2008?
Give a very brief answer. 24.98. What is the difference between the Claims(annual growth as % of broad money) in Colombia in 2006 and the Claims(annual growth as % of broad money) in Venezuela in 2008?
Keep it short and to the point. 8.62. What is the difference between the Claims(annual growth as % of broad money) in Jamaica in 2006 and the Claims(annual growth as % of broad money) in Mexico in 2008?
Give a very brief answer. 7.17. What is the difference between the Claims(annual growth as % of broad money) in Jamaica in 2006 and the Claims(annual growth as % of broad money) in Venezuela in 2008?
Keep it short and to the point. -9.2. What is the difference between the Claims(annual growth as % of broad money) in Mexico in 2006 and the Claims(annual growth as % of broad money) in Venezuela in 2008?
Keep it short and to the point. -1.53. What is the difference between the Claims(annual growth as % of broad money) of Colombia in 2006 and the Claims(annual growth as % of broad money) of Jamaica in 2009?
Offer a terse response. 25.56. What is the difference between the Claims(annual growth as % of broad money) in Colombia in 2006 and the Claims(annual growth as % of broad money) in Mexico in 2009?
Give a very brief answer. 22.99. What is the difference between the Claims(annual growth as % of broad money) of Colombia in 2006 and the Claims(annual growth as % of broad money) of Venezuela in 2009?
Give a very brief answer. 16.19. What is the difference between the Claims(annual growth as % of broad money) in Jamaica in 2006 and the Claims(annual growth as % of broad money) in Mexico in 2009?
Give a very brief answer. 5.17. What is the difference between the Claims(annual growth as % of broad money) of Jamaica in 2006 and the Claims(annual growth as % of broad money) of Venezuela in 2009?
Your answer should be very brief. -1.62. What is the difference between the Claims(annual growth as % of broad money) in Mexico in 2006 and the Claims(annual growth as % of broad money) in Venezuela in 2009?
Your answer should be very brief. 6.04. What is the difference between the Claims(annual growth as % of broad money) of Colombia in 2007 and the Claims(annual growth as % of broad money) of Jamaica in 2008?
Your response must be concise. 9.68. What is the difference between the Claims(annual growth as % of broad money) in Colombia in 2007 and the Claims(annual growth as % of broad money) in Mexico in 2008?
Keep it short and to the point. 20.42. What is the difference between the Claims(annual growth as % of broad money) in Colombia in 2007 and the Claims(annual growth as % of broad money) in Venezuela in 2008?
Your answer should be compact. 4.05. What is the difference between the Claims(annual growth as % of broad money) in Jamaica in 2007 and the Claims(annual growth as % of broad money) in Mexico in 2008?
Your answer should be compact. 10.76. What is the difference between the Claims(annual growth as % of broad money) of Jamaica in 2007 and the Claims(annual growth as % of broad money) of Venezuela in 2008?
Ensure brevity in your answer.  -5.6. What is the difference between the Claims(annual growth as % of broad money) in Mexico in 2007 and the Claims(annual growth as % of broad money) in Venezuela in 2008?
Offer a very short reply. -6.1. What is the difference between the Claims(annual growth as % of broad money) of Colombia in 2007 and the Claims(annual growth as % of broad money) of Jamaica in 2009?
Give a very brief answer. 21. What is the difference between the Claims(annual growth as % of broad money) of Colombia in 2007 and the Claims(annual growth as % of broad money) of Mexico in 2009?
Ensure brevity in your answer.  18.42. What is the difference between the Claims(annual growth as % of broad money) in Colombia in 2007 and the Claims(annual growth as % of broad money) in Venezuela in 2009?
Your response must be concise. 11.63. What is the difference between the Claims(annual growth as % of broad money) in Jamaica in 2007 and the Claims(annual growth as % of broad money) in Mexico in 2009?
Your response must be concise. 8.77. What is the difference between the Claims(annual growth as % of broad money) of Jamaica in 2007 and the Claims(annual growth as % of broad money) of Venezuela in 2009?
Give a very brief answer. 1.97. What is the difference between the Claims(annual growth as % of broad money) in Mexico in 2007 and the Claims(annual growth as % of broad money) in Venezuela in 2009?
Give a very brief answer. 1.48. What is the difference between the Claims(annual growth as % of broad money) in Colombia in 2008 and the Claims(annual growth as % of broad money) in Jamaica in 2009?
Offer a terse response. 12.05. What is the difference between the Claims(annual growth as % of broad money) in Colombia in 2008 and the Claims(annual growth as % of broad money) in Mexico in 2009?
Keep it short and to the point. 9.47. What is the difference between the Claims(annual growth as % of broad money) in Colombia in 2008 and the Claims(annual growth as % of broad money) in Venezuela in 2009?
Your response must be concise. 2.68. What is the difference between the Claims(annual growth as % of broad money) in Jamaica in 2008 and the Claims(annual growth as % of broad money) in Mexico in 2009?
Offer a terse response. 8.74. What is the difference between the Claims(annual growth as % of broad money) in Jamaica in 2008 and the Claims(annual growth as % of broad money) in Venezuela in 2009?
Your answer should be very brief. 1.95. What is the difference between the Claims(annual growth as % of broad money) of Mexico in 2008 and the Claims(annual growth as % of broad money) of Venezuela in 2009?
Keep it short and to the point. -8.79. What is the average Claims(annual growth as % of broad money) of Colombia per year?
Provide a succinct answer. 12.22. What is the average Claims(annual growth as % of broad money) of Jamaica per year?
Provide a short and direct response. 7.54. What is the average Claims(annual growth as % of broad money) in Mexico per year?
Make the answer very short. 7.17. What is the average Claims(annual growth as % of broad money) in Venezuela per year?
Provide a short and direct response. 22.4. In the year 2002, what is the difference between the Claims(annual growth as % of broad money) of Colombia and Claims(annual growth as % of broad money) of Jamaica?
Offer a very short reply. 0.48. In the year 2002, what is the difference between the Claims(annual growth as % of broad money) in Colombia and Claims(annual growth as % of broad money) in Mexico?
Offer a terse response. -3.9. In the year 2002, what is the difference between the Claims(annual growth as % of broad money) of Jamaica and Claims(annual growth as % of broad money) of Mexico?
Your answer should be very brief. -4.37. In the year 2003, what is the difference between the Claims(annual growth as % of broad money) of Colombia and Claims(annual growth as % of broad money) of Jamaica?
Your answer should be very brief. -2.72. In the year 2003, what is the difference between the Claims(annual growth as % of broad money) of Colombia and Claims(annual growth as % of broad money) of Mexico?
Your answer should be very brief. 2.95. In the year 2003, what is the difference between the Claims(annual growth as % of broad money) in Colombia and Claims(annual growth as % of broad money) in Venezuela?
Provide a short and direct response. 1.67. In the year 2003, what is the difference between the Claims(annual growth as % of broad money) of Jamaica and Claims(annual growth as % of broad money) of Mexico?
Ensure brevity in your answer.  5.68. In the year 2003, what is the difference between the Claims(annual growth as % of broad money) of Jamaica and Claims(annual growth as % of broad money) of Venezuela?
Offer a very short reply. 4.4. In the year 2003, what is the difference between the Claims(annual growth as % of broad money) of Mexico and Claims(annual growth as % of broad money) of Venezuela?
Keep it short and to the point. -1.28. In the year 2004, what is the difference between the Claims(annual growth as % of broad money) of Colombia and Claims(annual growth as % of broad money) of Jamaica?
Offer a very short reply. 7.27. In the year 2004, what is the difference between the Claims(annual growth as % of broad money) of Colombia and Claims(annual growth as % of broad money) of Mexico?
Provide a succinct answer. 11.01. In the year 2004, what is the difference between the Claims(annual growth as % of broad money) in Colombia and Claims(annual growth as % of broad money) in Venezuela?
Your answer should be very brief. -21.02. In the year 2004, what is the difference between the Claims(annual growth as % of broad money) of Jamaica and Claims(annual growth as % of broad money) of Mexico?
Your answer should be very brief. 3.74. In the year 2004, what is the difference between the Claims(annual growth as % of broad money) of Jamaica and Claims(annual growth as % of broad money) of Venezuela?
Provide a short and direct response. -28.29. In the year 2004, what is the difference between the Claims(annual growth as % of broad money) in Mexico and Claims(annual growth as % of broad money) in Venezuela?
Offer a very short reply. -32.03. In the year 2005, what is the difference between the Claims(annual growth as % of broad money) of Colombia and Claims(annual growth as % of broad money) of Jamaica?
Offer a very short reply. 4.08. In the year 2005, what is the difference between the Claims(annual growth as % of broad money) of Colombia and Claims(annual growth as % of broad money) of Mexico?
Ensure brevity in your answer.  0.95. In the year 2005, what is the difference between the Claims(annual growth as % of broad money) of Colombia and Claims(annual growth as % of broad money) of Venezuela?
Ensure brevity in your answer.  -24.35. In the year 2005, what is the difference between the Claims(annual growth as % of broad money) of Jamaica and Claims(annual growth as % of broad money) of Mexico?
Provide a short and direct response. -3.12. In the year 2005, what is the difference between the Claims(annual growth as % of broad money) in Jamaica and Claims(annual growth as % of broad money) in Venezuela?
Ensure brevity in your answer.  -28.43. In the year 2005, what is the difference between the Claims(annual growth as % of broad money) of Mexico and Claims(annual growth as % of broad money) of Venezuela?
Provide a short and direct response. -25.3. In the year 2006, what is the difference between the Claims(annual growth as % of broad money) in Colombia and Claims(annual growth as % of broad money) in Jamaica?
Offer a terse response. 17.81. In the year 2006, what is the difference between the Claims(annual growth as % of broad money) in Colombia and Claims(annual growth as % of broad money) in Mexico?
Offer a very short reply. 10.15. In the year 2006, what is the difference between the Claims(annual growth as % of broad money) of Colombia and Claims(annual growth as % of broad money) of Venezuela?
Keep it short and to the point. -11.15. In the year 2006, what is the difference between the Claims(annual growth as % of broad money) in Jamaica and Claims(annual growth as % of broad money) in Mexico?
Your answer should be compact. -7.66. In the year 2006, what is the difference between the Claims(annual growth as % of broad money) in Jamaica and Claims(annual growth as % of broad money) in Venezuela?
Provide a succinct answer. -28.97. In the year 2006, what is the difference between the Claims(annual growth as % of broad money) of Mexico and Claims(annual growth as % of broad money) of Venezuela?
Offer a very short reply. -21.3. In the year 2007, what is the difference between the Claims(annual growth as % of broad money) of Colombia and Claims(annual growth as % of broad money) of Jamaica?
Offer a very short reply. 9.65. In the year 2007, what is the difference between the Claims(annual growth as % of broad money) of Colombia and Claims(annual growth as % of broad money) of Mexico?
Ensure brevity in your answer.  10.15. In the year 2007, what is the difference between the Claims(annual growth as % of broad money) in Colombia and Claims(annual growth as % of broad money) in Venezuela?
Offer a very short reply. -17.73. In the year 2007, what is the difference between the Claims(annual growth as % of broad money) of Jamaica and Claims(annual growth as % of broad money) of Mexico?
Make the answer very short. 0.49. In the year 2007, what is the difference between the Claims(annual growth as % of broad money) in Jamaica and Claims(annual growth as % of broad money) in Venezuela?
Make the answer very short. -27.39. In the year 2007, what is the difference between the Claims(annual growth as % of broad money) in Mexico and Claims(annual growth as % of broad money) in Venezuela?
Offer a very short reply. -27.88. In the year 2008, what is the difference between the Claims(annual growth as % of broad money) of Colombia and Claims(annual growth as % of broad money) of Jamaica?
Give a very brief answer. 0.73. In the year 2008, what is the difference between the Claims(annual growth as % of broad money) of Colombia and Claims(annual growth as % of broad money) of Mexico?
Give a very brief answer. 11.47. In the year 2008, what is the difference between the Claims(annual growth as % of broad money) in Colombia and Claims(annual growth as % of broad money) in Venezuela?
Keep it short and to the point. -4.9. In the year 2008, what is the difference between the Claims(annual growth as % of broad money) in Jamaica and Claims(annual growth as % of broad money) in Mexico?
Keep it short and to the point. 10.74. In the year 2008, what is the difference between the Claims(annual growth as % of broad money) in Jamaica and Claims(annual growth as % of broad money) in Venezuela?
Give a very brief answer. -5.63. In the year 2008, what is the difference between the Claims(annual growth as % of broad money) in Mexico and Claims(annual growth as % of broad money) in Venezuela?
Make the answer very short. -16.37. In the year 2009, what is the difference between the Claims(annual growth as % of broad money) of Colombia and Claims(annual growth as % of broad money) of Jamaica?
Offer a terse response. 0.15. In the year 2009, what is the difference between the Claims(annual growth as % of broad money) in Colombia and Claims(annual growth as % of broad money) in Mexico?
Ensure brevity in your answer.  -2.42. In the year 2009, what is the difference between the Claims(annual growth as % of broad money) in Colombia and Claims(annual growth as % of broad money) in Venezuela?
Your response must be concise. -9.22. In the year 2009, what is the difference between the Claims(annual growth as % of broad money) in Jamaica and Claims(annual growth as % of broad money) in Mexico?
Keep it short and to the point. -2.58. In the year 2009, what is the difference between the Claims(annual growth as % of broad money) of Jamaica and Claims(annual growth as % of broad money) of Venezuela?
Make the answer very short. -9.37. In the year 2009, what is the difference between the Claims(annual growth as % of broad money) in Mexico and Claims(annual growth as % of broad money) in Venezuela?
Provide a short and direct response. -6.79. What is the ratio of the Claims(annual growth as % of broad money) in Colombia in 2002 to that in 2003?
Your response must be concise. 0.76. What is the ratio of the Claims(annual growth as % of broad money) in Jamaica in 2002 to that in 2003?
Make the answer very short. 0.5. What is the ratio of the Claims(annual growth as % of broad money) in Mexico in 2002 to that in 2003?
Provide a short and direct response. 2.35. What is the ratio of the Claims(annual growth as % of broad money) in Colombia in 2002 to that in 2004?
Ensure brevity in your answer.  0.36. What is the ratio of the Claims(annual growth as % of broad money) in Jamaica in 2002 to that in 2004?
Provide a short and direct response. 0.64. What is the ratio of the Claims(annual growth as % of broad money) in Mexico in 2002 to that in 2004?
Offer a terse response. 2.53. What is the ratio of the Claims(annual growth as % of broad money) in Colombia in 2002 to that in 2005?
Offer a terse response. 0.54. What is the ratio of the Claims(annual growth as % of broad money) of Jamaica in 2002 to that in 2005?
Offer a terse response. 0.85. What is the ratio of the Claims(annual growth as % of broad money) in Mexico in 2002 to that in 2005?
Your response must be concise. 1.05. What is the ratio of the Claims(annual growth as % of broad money) of Colombia in 2002 to that in 2006?
Offer a very short reply. 0.2. What is the ratio of the Claims(annual growth as % of broad money) in Jamaica in 2002 to that in 2006?
Offer a terse response. 0.56. What is the ratio of the Claims(annual growth as % of broad money) of Mexico in 2002 to that in 2006?
Provide a short and direct response. 0.57. What is the ratio of the Claims(annual growth as % of broad money) of Colombia in 2002 to that in 2007?
Provide a succinct answer. 0.24. What is the ratio of the Claims(annual growth as % of broad money) in Jamaica in 2002 to that in 2007?
Offer a terse response. 0.39. What is the ratio of the Claims(annual growth as % of broad money) of Mexico in 2002 to that in 2007?
Offer a terse response. 0.79. What is the ratio of the Claims(annual growth as % of broad money) in Colombia in 2002 to that in 2008?
Make the answer very short. 0.41. What is the ratio of the Claims(annual growth as % of broad money) of Jamaica in 2002 to that in 2008?
Provide a short and direct response. 0.4. What is the ratio of the Claims(annual growth as % of broad money) in Mexico in 2002 to that in 2008?
Offer a terse response. 7.34. What is the ratio of the Claims(annual growth as % of broad money) in Colombia in 2002 to that in 2009?
Keep it short and to the point. 6.38. What is the ratio of the Claims(annual growth as % of broad money) of Jamaica in 2002 to that in 2009?
Offer a very short reply. 7.13. What is the ratio of the Claims(annual growth as % of broad money) of Mexico in 2002 to that in 2009?
Your answer should be very brief. 2.81. What is the ratio of the Claims(annual growth as % of broad money) in Colombia in 2003 to that in 2004?
Provide a short and direct response. 0.47. What is the ratio of the Claims(annual growth as % of broad money) in Jamaica in 2003 to that in 2004?
Provide a succinct answer. 1.3. What is the ratio of the Claims(annual growth as % of broad money) in Mexico in 2003 to that in 2004?
Your answer should be compact. 1.07. What is the ratio of the Claims(annual growth as % of broad money) in Venezuela in 2003 to that in 2004?
Your response must be concise. 0.14. What is the ratio of the Claims(annual growth as % of broad money) of Colombia in 2003 to that in 2005?
Ensure brevity in your answer.  0.71. What is the ratio of the Claims(annual growth as % of broad money) of Jamaica in 2003 to that in 2005?
Give a very brief answer. 1.71. What is the ratio of the Claims(annual growth as % of broad money) of Mexico in 2003 to that in 2005?
Offer a terse response. 0.45. What is the ratio of the Claims(annual growth as % of broad money) in Venezuela in 2003 to that in 2005?
Your response must be concise. 0.15. What is the ratio of the Claims(annual growth as % of broad money) in Colombia in 2003 to that in 2006?
Offer a terse response. 0.26. What is the ratio of the Claims(annual growth as % of broad money) in Jamaica in 2003 to that in 2006?
Offer a very short reply. 1.13. What is the ratio of the Claims(annual growth as % of broad money) in Mexico in 2003 to that in 2006?
Keep it short and to the point. 0.24. What is the ratio of the Claims(annual growth as % of broad money) of Venezuela in 2003 to that in 2006?
Ensure brevity in your answer.  0.14. What is the ratio of the Claims(annual growth as % of broad money) of Colombia in 2003 to that in 2007?
Your answer should be compact. 0.32. What is the ratio of the Claims(annual growth as % of broad money) of Jamaica in 2003 to that in 2007?
Offer a terse response. 0.8. What is the ratio of the Claims(annual growth as % of broad money) of Mexico in 2003 to that in 2007?
Offer a very short reply. 0.34. What is the ratio of the Claims(annual growth as % of broad money) of Venezuela in 2003 to that in 2007?
Give a very brief answer. 0.13. What is the ratio of the Claims(annual growth as % of broad money) in Colombia in 2003 to that in 2008?
Your response must be concise. 0.54. What is the ratio of the Claims(annual growth as % of broad money) of Jamaica in 2003 to that in 2008?
Provide a succinct answer. 0.8. What is the ratio of the Claims(annual growth as % of broad money) in Mexico in 2003 to that in 2008?
Ensure brevity in your answer.  3.12. What is the ratio of the Claims(annual growth as % of broad money) of Venezuela in 2003 to that in 2008?
Give a very brief answer. 0.29. What is the ratio of the Claims(annual growth as % of broad money) of Colombia in 2003 to that in 2009?
Your answer should be very brief. 8.35. What is the ratio of the Claims(annual growth as % of broad money) in Jamaica in 2003 to that in 2009?
Offer a terse response. 14.37. What is the ratio of the Claims(annual growth as % of broad money) of Mexico in 2003 to that in 2009?
Offer a very short reply. 1.2. What is the ratio of the Claims(annual growth as % of broad money) of Venezuela in 2003 to that in 2009?
Keep it short and to the point. 0.51. What is the ratio of the Claims(annual growth as % of broad money) of Colombia in 2004 to that in 2005?
Offer a terse response. 1.51. What is the ratio of the Claims(annual growth as % of broad money) in Jamaica in 2004 to that in 2005?
Provide a succinct answer. 1.32. What is the ratio of the Claims(annual growth as % of broad money) of Mexico in 2004 to that in 2005?
Your answer should be very brief. 0.41. What is the ratio of the Claims(annual growth as % of broad money) of Venezuela in 2004 to that in 2005?
Make the answer very short. 1.05. What is the ratio of the Claims(annual growth as % of broad money) in Colombia in 2004 to that in 2006?
Provide a short and direct response. 0.56. What is the ratio of the Claims(annual growth as % of broad money) in Jamaica in 2004 to that in 2006?
Provide a short and direct response. 0.87. What is the ratio of the Claims(annual growth as % of broad money) of Mexico in 2004 to that in 2006?
Offer a very short reply. 0.22. What is the ratio of the Claims(annual growth as % of broad money) of Venezuela in 2004 to that in 2006?
Your answer should be compact. 0.95. What is the ratio of the Claims(annual growth as % of broad money) of Colombia in 2004 to that in 2007?
Your response must be concise. 0.68. What is the ratio of the Claims(annual growth as % of broad money) of Jamaica in 2004 to that in 2007?
Ensure brevity in your answer.  0.61. What is the ratio of the Claims(annual growth as % of broad money) of Mexico in 2004 to that in 2007?
Your answer should be compact. 0.31. What is the ratio of the Claims(annual growth as % of broad money) of Venezuela in 2004 to that in 2007?
Your answer should be very brief. 0.9. What is the ratio of the Claims(annual growth as % of broad money) in Colombia in 2004 to that in 2008?
Provide a succinct answer. 1.15. What is the ratio of the Claims(annual growth as % of broad money) in Jamaica in 2004 to that in 2008?
Provide a succinct answer. 0.61. What is the ratio of the Claims(annual growth as % of broad money) of Mexico in 2004 to that in 2008?
Ensure brevity in your answer.  2.9. What is the ratio of the Claims(annual growth as % of broad money) in Venezuela in 2004 to that in 2008?
Ensure brevity in your answer.  2.02. What is the ratio of the Claims(annual growth as % of broad money) in Colombia in 2004 to that in 2009?
Provide a short and direct response. 17.9. What is the ratio of the Claims(annual growth as % of broad money) in Jamaica in 2004 to that in 2009?
Your answer should be very brief. 11.07. What is the ratio of the Claims(annual growth as % of broad money) of Mexico in 2004 to that in 2009?
Your answer should be compact. 1.11. What is the ratio of the Claims(annual growth as % of broad money) in Venezuela in 2004 to that in 2009?
Offer a very short reply. 3.55. What is the ratio of the Claims(annual growth as % of broad money) in Colombia in 2005 to that in 2006?
Offer a terse response. 0.37. What is the ratio of the Claims(annual growth as % of broad money) of Jamaica in 2005 to that in 2006?
Your answer should be compact. 0.66. What is the ratio of the Claims(annual growth as % of broad money) in Mexico in 2005 to that in 2006?
Provide a short and direct response. 0.54. What is the ratio of the Claims(annual growth as % of broad money) of Venezuela in 2005 to that in 2006?
Your response must be concise. 0.91. What is the ratio of the Claims(annual growth as % of broad money) in Colombia in 2005 to that in 2007?
Ensure brevity in your answer.  0.45. What is the ratio of the Claims(annual growth as % of broad money) of Jamaica in 2005 to that in 2007?
Your response must be concise. 0.46. What is the ratio of the Claims(annual growth as % of broad money) of Mexico in 2005 to that in 2007?
Provide a short and direct response. 0.76. What is the ratio of the Claims(annual growth as % of broad money) of Venezuela in 2005 to that in 2007?
Your response must be concise. 0.86. What is the ratio of the Claims(annual growth as % of broad money) in Colombia in 2005 to that in 2008?
Make the answer very short. 0.76. What is the ratio of the Claims(annual growth as % of broad money) in Jamaica in 2005 to that in 2008?
Offer a terse response. 0.47. What is the ratio of the Claims(annual growth as % of broad money) of Mexico in 2005 to that in 2008?
Give a very brief answer. 7. What is the ratio of the Claims(annual growth as % of broad money) of Venezuela in 2005 to that in 2008?
Offer a very short reply. 1.93. What is the ratio of the Claims(annual growth as % of broad money) of Colombia in 2005 to that in 2009?
Your response must be concise. 11.82. What is the ratio of the Claims(annual growth as % of broad money) of Jamaica in 2005 to that in 2009?
Your answer should be very brief. 8.39. What is the ratio of the Claims(annual growth as % of broad money) in Mexico in 2005 to that in 2009?
Keep it short and to the point. 2.69. What is the ratio of the Claims(annual growth as % of broad money) of Venezuela in 2005 to that in 2009?
Give a very brief answer. 3.39. What is the ratio of the Claims(annual growth as % of broad money) of Colombia in 2006 to that in 2007?
Offer a very short reply. 1.21. What is the ratio of the Claims(annual growth as % of broad money) of Jamaica in 2006 to that in 2007?
Provide a succinct answer. 0.7. What is the ratio of the Claims(annual growth as % of broad money) in Mexico in 2006 to that in 2007?
Make the answer very short. 1.4. What is the ratio of the Claims(annual growth as % of broad money) of Venezuela in 2006 to that in 2007?
Provide a short and direct response. 0.95. What is the ratio of the Claims(annual growth as % of broad money) in Colombia in 2006 to that in 2008?
Your response must be concise. 2.06. What is the ratio of the Claims(annual growth as % of broad money) of Jamaica in 2006 to that in 2008?
Your answer should be compact. 0.7. What is the ratio of the Claims(annual growth as % of broad money) of Mexico in 2006 to that in 2008?
Give a very brief answer. 12.94. What is the ratio of the Claims(annual growth as % of broad money) of Venezuela in 2006 to that in 2008?
Offer a terse response. 2.12. What is the ratio of the Claims(annual growth as % of broad money) in Colombia in 2006 to that in 2009?
Ensure brevity in your answer.  32.1. What is the ratio of the Claims(annual growth as % of broad money) of Jamaica in 2006 to that in 2009?
Offer a very short reply. 12.66. What is the ratio of the Claims(annual growth as % of broad money) in Mexico in 2006 to that in 2009?
Your response must be concise. 4.96. What is the ratio of the Claims(annual growth as % of broad money) in Venezuela in 2006 to that in 2009?
Ensure brevity in your answer.  3.73. What is the ratio of the Claims(annual growth as % of broad money) in Colombia in 2007 to that in 2008?
Offer a very short reply. 1.7. What is the ratio of the Claims(annual growth as % of broad money) of Mexico in 2007 to that in 2008?
Offer a very short reply. 9.27. What is the ratio of the Claims(annual growth as % of broad money) in Venezuela in 2007 to that in 2008?
Offer a terse response. 2.24. What is the ratio of the Claims(annual growth as % of broad money) of Colombia in 2007 to that in 2009?
Keep it short and to the point. 26.51. What is the ratio of the Claims(annual growth as % of broad money) in Jamaica in 2007 to that in 2009?
Keep it short and to the point. 18.07. What is the ratio of the Claims(annual growth as % of broad money) in Mexico in 2007 to that in 2009?
Provide a succinct answer. 3.55. What is the ratio of the Claims(annual growth as % of broad money) in Venezuela in 2007 to that in 2009?
Your response must be concise. 3.93. What is the ratio of the Claims(annual growth as % of broad money) in Colombia in 2008 to that in 2009?
Your answer should be very brief. 15.56. What is the ratio of the Claims(annual growth as % of broad money) of Jamaica in 2008 to that in 2009?
Your answer should be very brief. 18.03. What is the ratio of the Claims(annual growth as % of broad money) of Mexico in 2008 to that in 2009?
Ensure brevity in your answer.  0.38. What is the ratio of the Claims(annual growth as % of broad money) in Venezuela in 2008 to that in 2009?
Your answer should be very brief. 1.75. What is the difference between the highest and the second highest Claims(annual growth as % of broad money) in Colombia?
Offer a terse response. 4.56. What is the difference between the highest and the second highest Claims(annual growth as % of broad money) in Jamaica?
Your answer should be very brief. 0.02. What is the difference between the highest and the second highest Claims(annual growth as % of broad money) in Mexico?
Provide a succinct answer. 4.56. What is the difference between the highest and the second highest Claims(annual growth as % of broad money) of Venezuela?
Provide a succinct answer. 2.01. What is the difference between the highest and the lowest Claims(annual growth as % of broad money) of Colombia?
Your answer should be very brief. 25.41. What is the difference between the highest and the lowest Claims(annual growth as % of broad money) in Jamaica?
Provide a succinct answer. 11.34. What is the difference between the highest and the lowest Claims(annual growth as % of broad money) in Mexico?
Your answer should be very brief. 14.83. What is the difference between the highest and the lowest Claims(annual growth as % of broad money) in Venezuela?
Your answer should be compact. 39.39. 